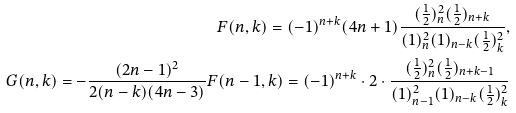Convert formula to latex. <formula><loc_0><loc_0><loc_500><loc_500>F ( n , k ) = ( - 1 ) ^ { n + k } ( 4 n + 1 ) \frac { ( \frac { 1 } { 2 } ) _ { n } ^ { 2 } ( \frac { 1 } { 2 } ) _ { n + k } } { ( 1 ) _ { n } ^ { 2 } ( 1 ) _ { n - k } ( \frac { 1 } { 2 } ) _ { k } ^ { 2 } } , \\ G ( n , k ) = - \frac { ( 2 n - 1 ) ^ { 2 } } { 2 ( n - k ) ( 4 n - 3 ) } F ( n - 1 , k ) = ( - 1 ) ^ { n + k } \cdot 2 \cdot \frac { ( \frac { 1 } { 2 } ) _ { n } ^ { 2 } ( \frac { 1 } { 2 } ) _ { n + k - 1 } } { ( 1 ) _ { n - 1 } ^ { 2 } ( 1 ) _ { n - k } ( \frac { 1 } { 2 } ) _ { k } ^ { 2 } }</formula> 